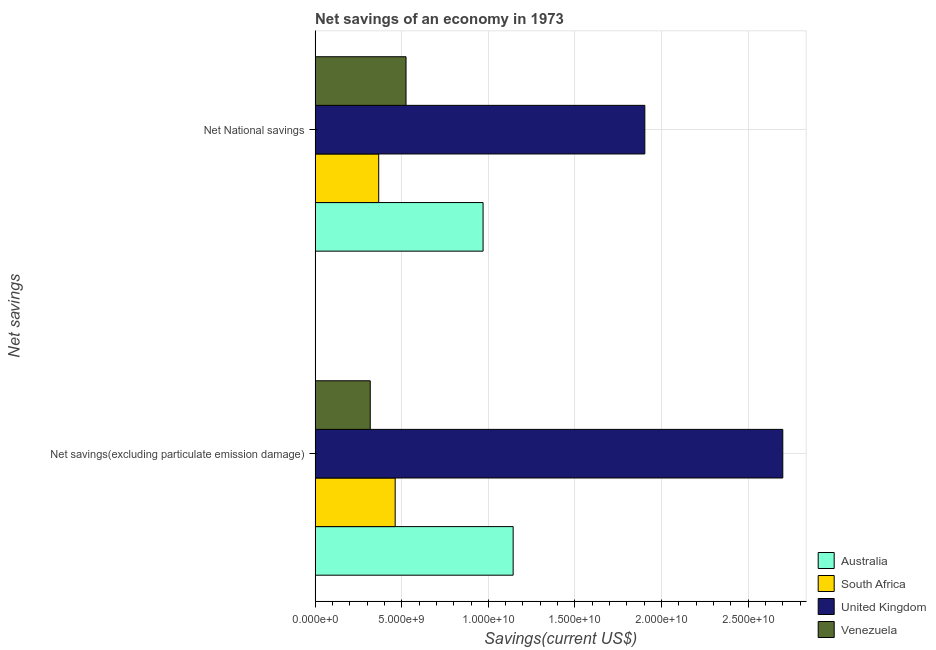Are the number of bars per tick equal to the number of legend labels?
Ensure brevity in your answer.  Yes. Are the number of bars on each tick of the Y-axis equal?
Provide a short and direct response. Yes. How many bars are there on the 1st tick from the top?
Provide a short and direct response. 4. How many bars are there on the 2nd tick from the bottom?
Ensure brevity in your answer.  4. What is the label of the 1st group of bars from the top?
Ensure brevity in your answer.  Net National savings. What is the net national savings in Venezuela?
Give a very brief answer. 5.25e+09. Across all countries, what is the maximum net savings(excluding particulate emission damage)?
Provide a short and direct response. 2.70e+1. Across all countries, what is the minimum net national savings?
Your answer should be very brief. 3.67e+09. In which country was the net savings(excluding particulate emission damage) maximum?
Give a very brief answer. United Kingdom. In which country was the net national savings minimum?
Offer a very short reply. South Africa. What is the total net savings(excluding particulate emission damage) in the graph?
Give a very brief answer. 4.62e+1. What is the difference between the net savings(excluding particulate emission damage) in South Africa and that in United Kingdom?
Offer a terse response. -2.24e+1. What is the difference between the net national savings in Australia and the net savings(excluding particulate emission damage) in United Kingdom?
Your answer should be compact. -1.73e+1. What is the average net national savings per country?
Keep it short and to the point. 9.41e+09. What is the difference between the net national savings and net savings(excluding particulate emission damage) in South Africa?
Your answer should be compact. -9.50e+08. In how many countries, is the net savings(excluding particulate emission damage) greater than 13000000000 US$?
Your answer should be compact. 1. What is the ratio of the net national savings in Australia to that in Venezuela?
Offer a terse response. 1.85. Is the net national savings in Australia less than that in Venezuela?
Ensure brevity in your answer.  No. What does the 3rd bar from the top in Net savings(excluding particulate emission damage) represents?
Your answer should be very brief. South Africa. Are all the bars in the graph horizontal?
Offer a very short reply. Yes. How many countries are there in the graph?
Offer a terse response. 4. Are the values on the major ticks of X-axis written in scientific E-notation?
Provide a succinct answer. Yes. Where does the legend appear in the graph?
Provide a short and direct response. Bottom right. How many legend labels are there?
Offer a terse response. 4. What is the title of the graph?
Keep it short and to the point. Net savings of an economy in 1973. What is the label or title of the X-axis?
Make the answer very short. Savings(current US$). What is the label or title of the Y-axis?
Ensure brevity in your answer.  Net savings. What is the Savings(current US$) in Australia in Net savings(excluding particulate emission damage)?
Provide a succinct answer. 1.14e+1. What is the Savings(current US$) of South Africa in Net savings(excluding particulate emission damage)?
Make the answer very short. 4.62e+09. What is the Savings(current US$) of United Kingdom in Net savings(excluding particulate emission damage)?
Keep it short and to the point. 2.70e+1. What is the Savings(current US$) in Venezuela in Net savings(excluding particulate emission damage)?
Ensure brevity in your answer.  3.18e+09. What is the Savings(current US$) in Australia in Net National savings?
Your answer should be compact. 9.70e+09. What is the Savings(current US$) in South Africa in Net National savings?
Offer a very short reply. 3.67e+09. What is the Savings(current US$) of United Kingdom in Net National savings?
Your answer should be very brief. 1.90e+1. What is the Savings(current US$) of Venezuela in Net National savings?
Provide a short and direct response. 5.25e+09. Across all Net savings, what is the maximum Savings(current US$) in Australia?
Offer a terse response. 1.14e+1. Across all Net savings, what is the maximum Savings(current US$) in South Africa?
Keep it short and to the point. 4.62e+09. Across all Net savings, what is the maximum Savings(current US$) in United Kingdom?
Provide a succinct answer. 2.70e+1. Across all Net savings, what is the maximum Savings(current US$) of Venezuela?
Your response must be concise. 5.25e+09. Across all Net savings, what is the minimum Savings(current US$) of Australia?
Ensure brevity in your answer.  9.70e+09. Across all Net savings, what is the minimum Savings(current US$) in South Africa?
Your response must be concise. 3.67e+09. Across all Net savings, what is the minimum Savings(current US$) in United Kingdom?
Provide a succinct answer. 1.90e+1. Across all Net savings, what is the minimum Savings(current US$) in Venezuela?
Offer a very short reply. 3.18e+09. What is the total Savings(current US$) in Australia in the graph?
Offer a terse response. 2.11e+1. What is the total Savings(current US$) in South Africa in the graph?
Provide a succinct answer. 8.29e+09. What is the total Savings(current US$) of United Kingdom in the graph?
Your response must be concise. 4.60e+1. What is the total Savings(current US$) in Venezuela in the graph?
Ensure brevity in your answer.  8.43e+09. What is the difference between the Savings(current US$) of Australia in Net savings(excluding particulate emission damage) and that in Net National savings?
Keep it short and to the point. 1.74e+09. What is the difference between the Savings(current US$) in South Africa in Net savings(excluding particulate emission damage) and that in Net National savings?
Make the answer very short. 9.50e+08. What is the difference between the Savings(current US$) in United Kingdom in Net savings(excluding particulate emission damage) and that in Net National savings?
Offer a very short reply. 7.96e+09. What is the difference between the Savings(current US$) in Venezuela in Net savings(excluding particulate emission damage) and that in Net National savings?
Your answer should be very brief. -2.07e+09. What is the difference between the Savings(current US$) of Australia in Net savings(excluding particulate emission damage) and the Savings(current US$) of South Africa in Net National savings?
Offer a terse response. 7.76e+09. What is the difference between the Savings(current US$) in Australia in Net savings(excluding particulate emission damage) and the Savings(current US$) in United Kingdom in Net National savings?
Give a very brief answer. -7.60e+09. What is the difference between the Savings(current US$) in Australia in Net savings(excluding particulate emission damage) and the Savings(current US$) in Venezuela in Net National savings?
Keep it short and to the point. 6.18e+09. What is the difference between the Savings(current US$) of South Africa in Net savings(excluding particulate emission damage) and the Savings(current US$) of United Kingdom in Net National savings?
Your response must be concise. -1.44e+1. What is the difference between the Savings(current US$) of South Africa in Net savings(excluding particulate emission damage) and the Savings(current US$) of Venezuela in Net National savings?
Provide a short and direct response. -6.27e+08. What is the difference between the Savings(current US$) in United Kingdom in Net savings(excluding particulate emission damage) and the Savings(current US$) in Venezuela in Net National savings?
Offer a terse response. 2.17e+1. What is the average Savings(current US$) of Australia per Net savings?
Provide a succinct answer. 1.06e+1. What is the average Savings(current US$) in South Africa per Net savings?
Offer a very short reply. 4.15e+09. What is the average Savings(current US$) of United Kingdom per Net savings?
Provide a succinct answer. 2.30e+1. What is the average Savings(current US$) of Venezuela per Net savings?
Offer a very short reply. 4.22e+09. What is the difference between the Savings(current US$) of Australia and Savings(current US$) of South Africa in Net savings(excluding particulate emission damage)?
Your answer should be very brief. 6.81e+09. What is the difference between the Savings(current US$) in Australia and Savings(current US$) in United Kingdom in Net savings(excluding particulate emission damage)?
Offer a very short reply. -1.56e+1. What is the difference between the Savings(current US$) in Australia and Savings(current US$) in Venezuela in Net savings(excluding particulate emission damage)?
Your answer should be compact. 8.25e+09. What is the difference between the Savings(current US$) of South Africa and Savings(current US$) of United Kingdom in Net savings(excluding particulate emission damage)?
Provide a succinct answer. -2.24e+1. What is the difference between the Savings(current US$) in South Africa and Savings(current US$) in Venezuela in Net savings(excluding particulate emission damage)?
Your answer should be very brief. 1.44e+09. What is the difference between the Savings(current US$) in United Kingdom and Savings(current US$) in Venezuela in Net savings(excluding particulate emission damage)?
Keep it short and to the point. 2.38e+1. What is the difference between the Savings(current US$) of Australia and Savings(current US$) of South Africa in Net National savings?
Provide a succinct answer. 6.03e+09. What is the difference between the Savings(current US$) of Australia and Savings(current US$) of United Kingdom in Net National savings?
Provide a succinct answer. -9.34e+09. What is the difference between the Savings(current US$) in Australia and Savings(current US$) in Venezuela in Net National savings?
Offer a terse response. 4.45e+09. What is the difference between the Savings(current US$) in South Africa and Savings(current US$) in United Kingdom in Net National savings?
Offer a terse response. -1.54e+1. What is the difference between the Savings(current US$) in South Africa and Savings(current US$) in Venezuela in Net National savings?
Your answer should be very brief. -1.58e+09. What is the difference between the Savings(current US$) of United Kingdom and Savings(current US$) of Venezuela in Net National savings?
Your response must be concise. 1.38e+1. What is the ratio of the Savings(current US$) in Australia in Net savings(excluding particulate emission damage) to that in Net National savings?
Your answer should be very brief. 1.18. What is the ratio of the Savings(current US$) of South Africa in Net savings(excluding particulate emission damage) to that in Net National savings?
Ensure brevity in your answer.  1.26. What is the ratio of the Savings(current US$) in United Kingdom in Net savings(excluding particulate emission damage) to that in Net National savings?
Provide a succinct answer. 1.42. What is the ratio of the Savings(current US$) in Venezuela in Net savings(excluding particulate emission damage) to that in Net National savings?
Your answer should be very brief. 0.61. What is the difference between the highest and the second highest Savings(current US$) in Australia?
Provide a succinct answer. 1.74e+09. What is the difference between the highest and the second highest Savings(current US$) of South Africa?
Provide a succinct answer. 9.50e+08. What is the difference between the highest and the second highest Savings(current US$) of United Kingdom?
Offer a very short reply. 7.96e+09. What is the difference between the highest and the second highest Savings(current US$) of Venezuela?
Ensure brevity in your answer.  2.07e+09. What is the difference between the highest and the lowest Savings(current US$) in Australia?
Your response must be concise. 1.74e+09. What is the difference between the highest and the lowest Savings(current US$) in South Africa?
Your response must be concise. 9.50e+08. What is the difference between the highest and the lowest Savings(current US$) of United Kingdom?
Provide a short and direct response. 7.96e+09. What is the difference between the highest and the lowest Savings(current US$) of Venezuela?
Ensure brevity in your answer.  2.07e+09. 